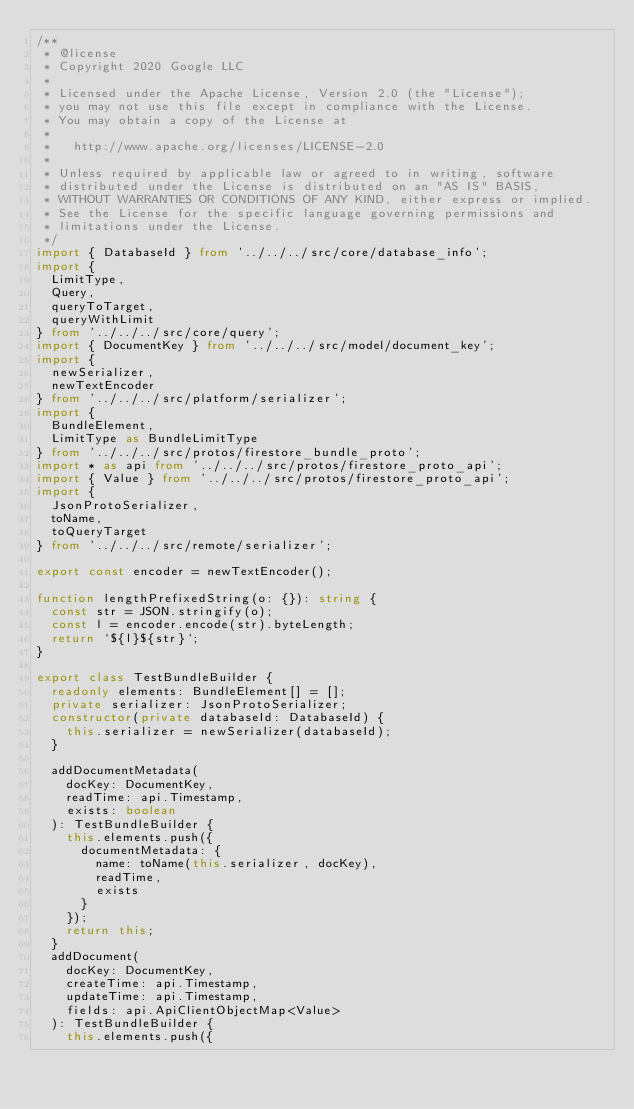Convert code to text. <code><loc_0><loc_0><loc_500><loc_500><_TypeScript_>/**
 * @license
 * Copyright 2020 Google LLC
 *
 * Licensed under the Apache License, Version 2.0 (the "License");
 * you may not use this file except in compliance with the License.
 * You may obtain a copy of the License at
 *
 *   http://www.apache.org/licenses/LICENSE-2.0
 *
 * Unless required by applicable law or agreed to in writing, software
 * distributed under the License is distributed on an "AS IS" BASIS,
 * WITHOUT WARRANTIES OR CONDITIONS OF ANY KIND, either express or implied.
 * See the License for the specific language governing permissions and
 * limitations under the License.
 */
import { DatabaseId } from '../../../src/core/database_info';
import {
  LimitType,
  Query,
  queryToTarget,
  queryWithLimit
} from '../../../src/core/query';
import { DocumentKey } from '../../../src/model/document_key';
import {
  newSerializer,
  newTextEncoder
} from '../../../src/platform/serializer';
import {
  BundleElement,
  LimitType as BundleLimitType
} from '../../../src/protos/firestore_bundle_proto';
import * as api from '../../../src/protos/firestore_proto_api';
import { Value } from '../../../src/protos/firestore_proto_api';
import {
  JsonProtoSerializer,
  toName,
  toQueryTarget
} from '../../../src/remote/serializer';

export const encoder = newTextEncoder();

function lengthPrefixedString(o: {}): string {
  const str = JSON.stringify(o);
  const l = encoder.encode(str).byteLength;
  return `${l}${str}`;
}

export class TestBundleBuilder {
  readonly elements: BundleElement[] = [];
  private serializer: JsonProtoSerializer;
  constructor(private databaseId: DatabaseId) {
    this.serializer = newSerializer(databaseId);
  }

  addDocumentMetadata(
    docKey: DocumentKey,
    readTime: api.Timestamp,
    exists: boolean
  ): TestBundleBuilder {
    this.elements.push({
      documentMetadata: {
        name: toName(this.serializer, docKey),
        readTime,
        exists
      }
    });
    return this;
  }
  addDocument(
    docKey: DocumentKey,
    createTime: api.Timestamp,
    updateTime: api.Timestamp,
    fields: api.ApiClientObjectMap<Value>
  ): TestBundleBuilder {
    this.elements.push({</code> 